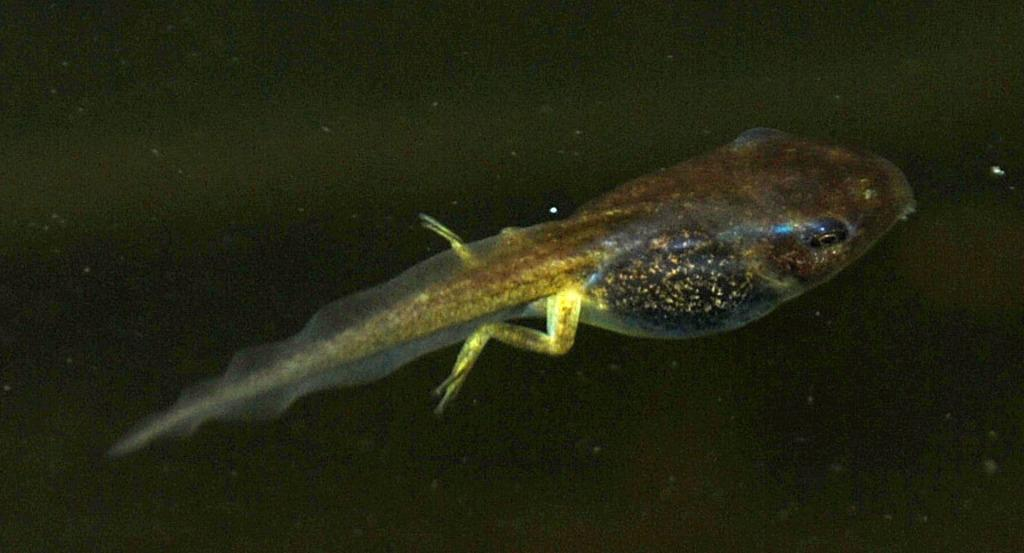What type of animal can be seen in the image? There is an aquatic animal in the image. Where was the image taken? The image was taken in water. What is the opinion of the floor on the aquatic animal in the image? There is no floor present in the image, as it was taken in water. Additionally, floors do not have opinions. 